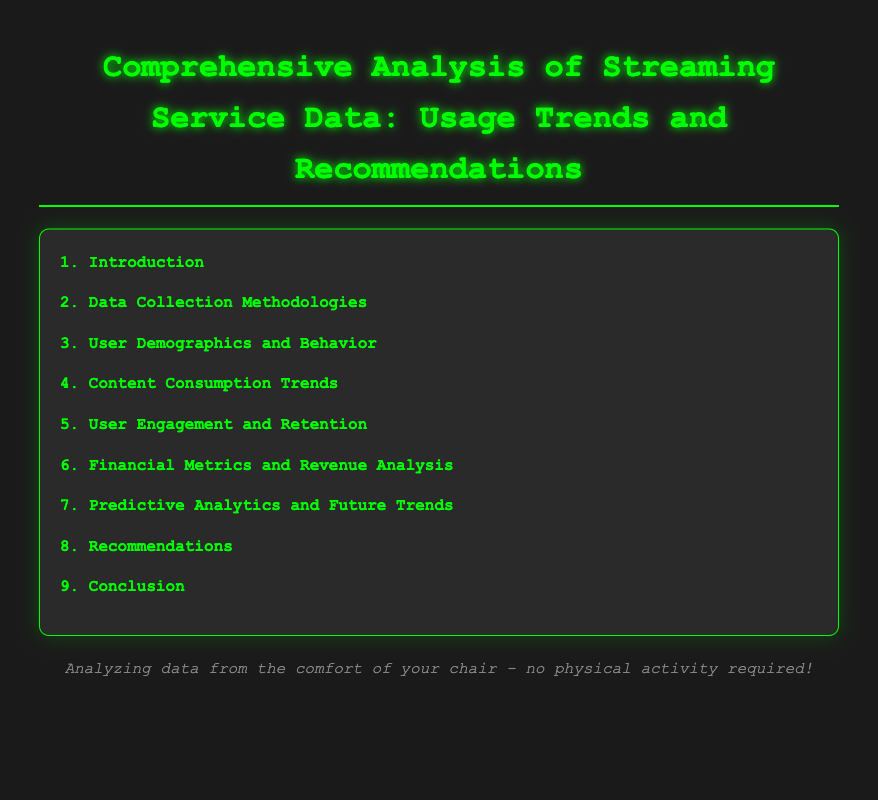what is the title of the document? The title of the document is located at the top of the rendered page, highlighting the subject matter.
Answer: Comprehensive Analysis of Streaming Service Data: Usage Trends and Recommendations how many main sections are in the document? The main sections can be counted in the Table of Contents, listing all primary topics covered.
Answer: 9 what does section 6 focus on? This section describes financial aspects related to streaming services, indicating its purpose.
Answer: Financial Metrics and Revenue Analysis which section discusses user engagement? This question looks for the section that specifically addresses how users interact with the service.
Answer: User Engagement and Retention what is the last sub-section under recommendations? This question asks for the specific sub-section listed last in the recommendations section.
Answer: Strategies for Reducing Churn which sub-section covers viewing habits? This question requires the identification of the specific sub-section that relates to how users watch content based on their geography.
Answer: Viewing Habits Based on Location what is the purpose of the document? This question intends to understand the aim of the document as stated in the introductory section.
Answer: To analyze streaming service data and provide recommendations how many sub-sections are in section 4? The number of sub-sections can be derived by counting the listed items under the relevant section in the Table of Contents.
Answer: 3 what is the first sub-section of the introduction? This question seeks the initial sub-section listed under the introduction section.
Answer: Overview of Streaming Services 